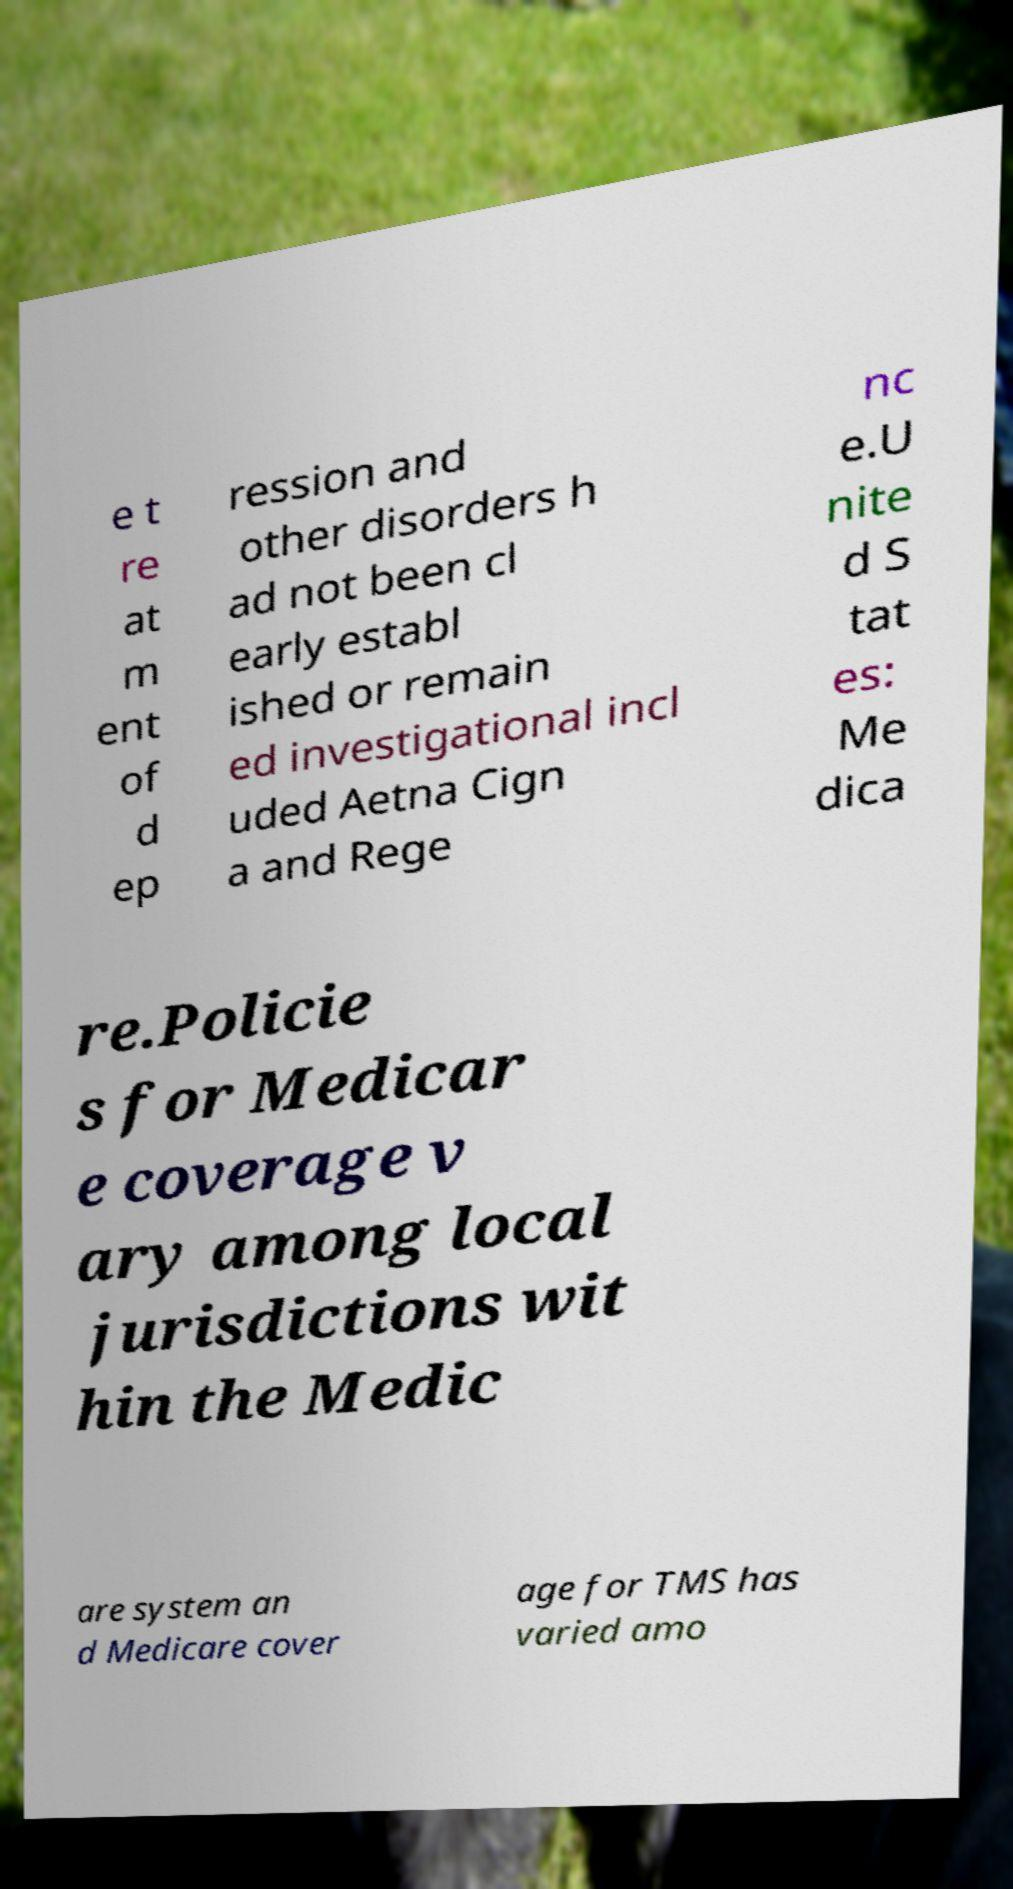Please read and relay the text visible in this image. What does it say? e t re at m ent of d ep ression and other disorders h ad not been cl early establ ished or remain ed investigational incl uded Aetna Cign a and Rege nc e.U nite d S tat es: Me dica re.Policie s for Medicar e coverage v ary among local jurisdictions wit hin the Medic are system an d Medicare cover age for TMS has varied amo 